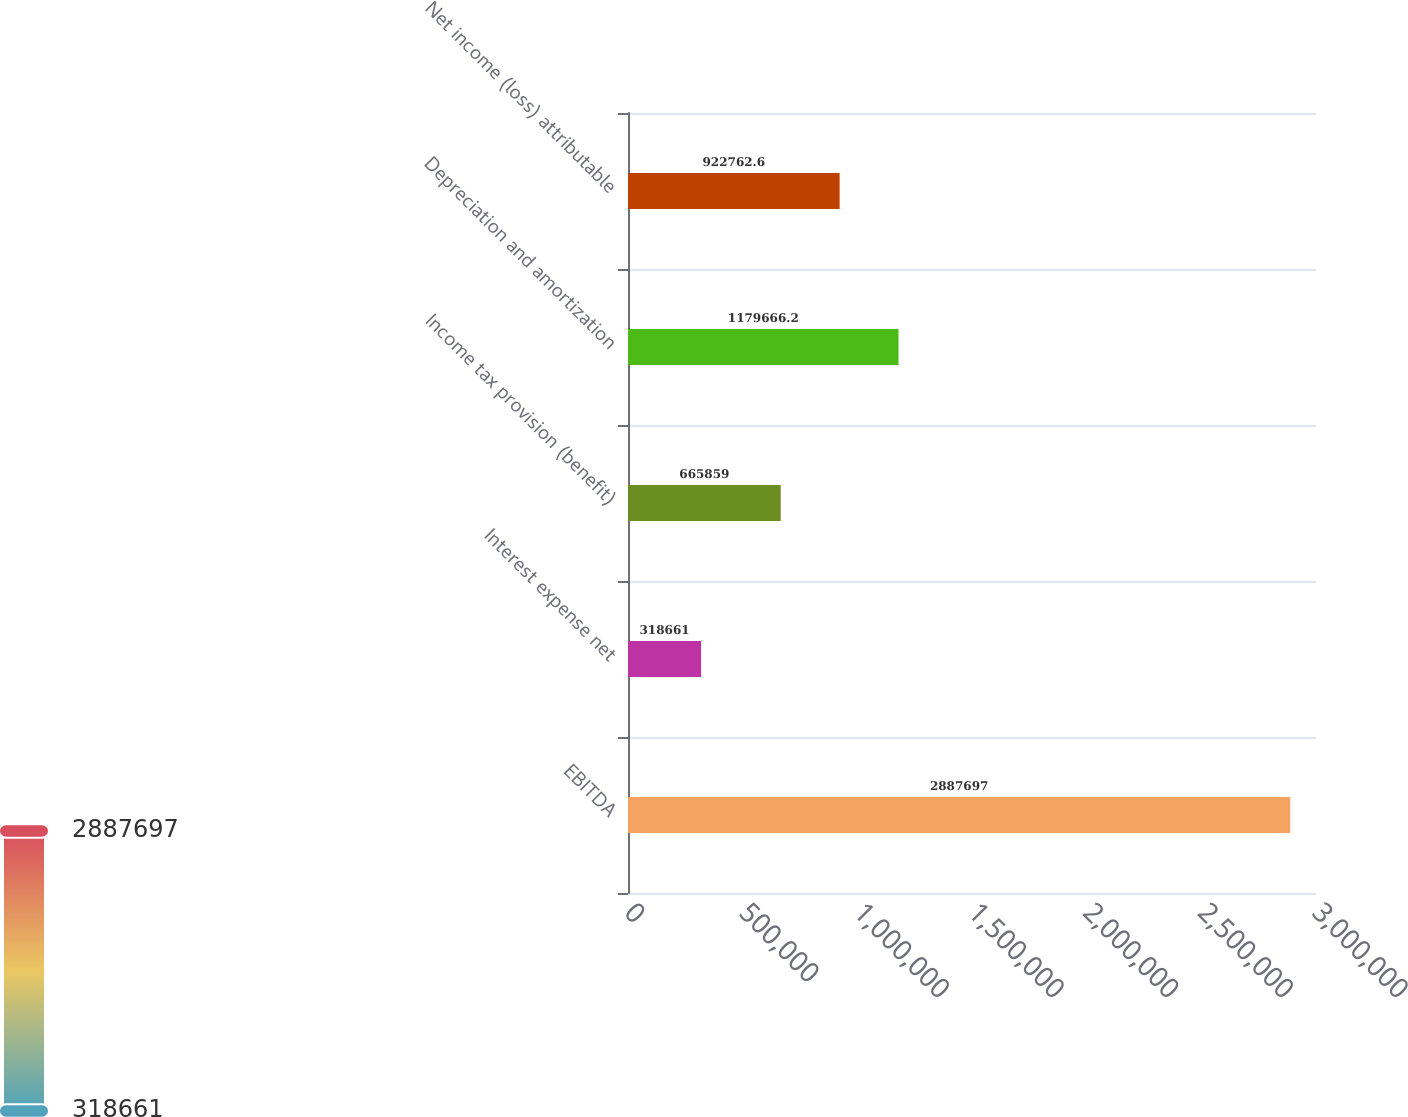Convert chart to OTSL. <chart><loc_0><loc_0><loc_500><loc_500><bar_chart><fcel>EBITDA<fcel>Interest expense net<fcel>Income tax provision (benefit)<fcel>Depreciation and amortization<fcel>Net income (loss) attributable<nl><fcel>2.8877e+06<fcel>318661<fcel>665859<fcel>1.17967e+06<fcel>922763<nl></chart> 